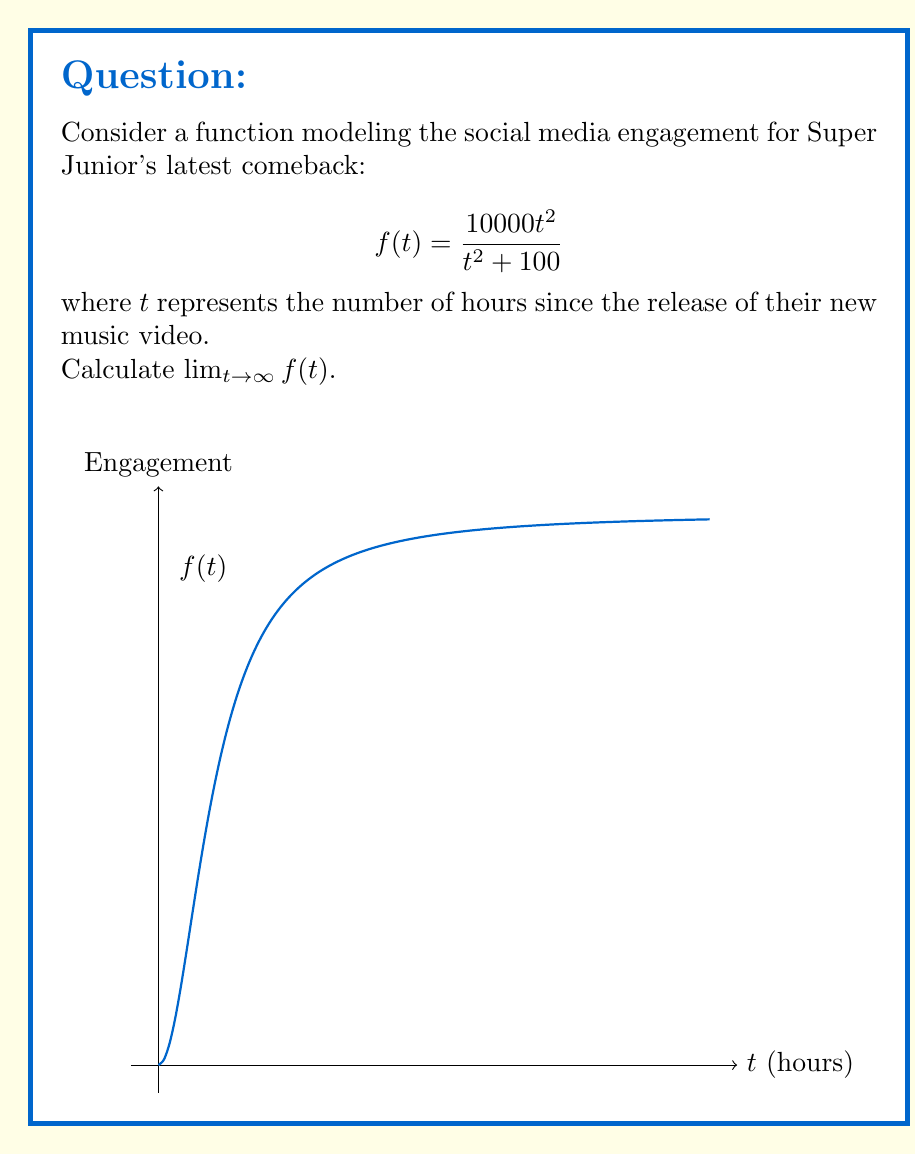Teach me how to tackle this problem. Let's approach this step-by-step:

1) To find the limit as $t$ approaches infinity, we need to analyze the behavior of the function for very large values of $t$.

2) Let's start by factoring out $t^2$ from both the numerator and denominator:

   $$\lim_{t \to \infty} f(t) = \lim_{t \to \infty} \frac{10000t^2}{t^2 + 100} = \lim_{t \to \infty} \frac{10000t^2/t^2}{(t^2 + 100)/t^2}$$

3) Simplify:

   $$\lim_{t \to \infty} \frac{10000}{1 + 100/t^2}$$

4) As $t$ approaches infinity, $100/t^2$ approaches 0:

   $$\lim_{t \to \infty} \frac{10000}{1 + 0} = \frac{10000}{1} = 10000$$

5) This result indicates that as time progresses, the engagement approaches but never exceeds 10,000 units (which could represent likes, shares, or comments).
Answer: $10000$ 